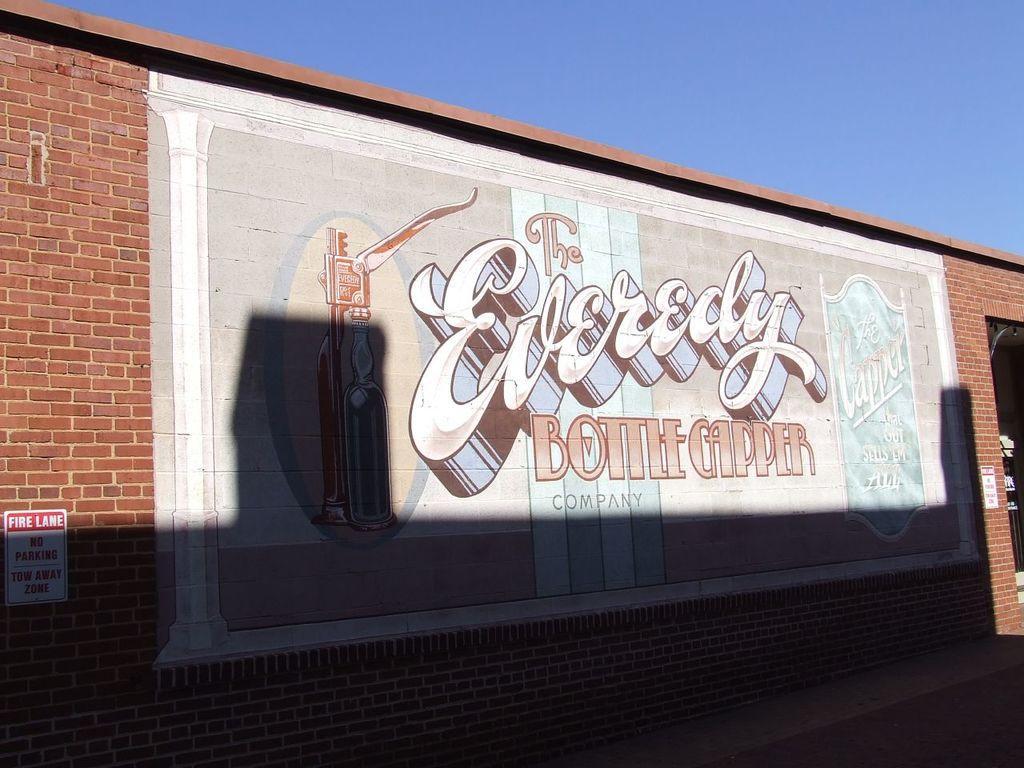Can you describe this image briefly? In this image we can see a wall and there is an art with some text and pictures on the wall and we can see a board with some text and at the top we can see the sky. 